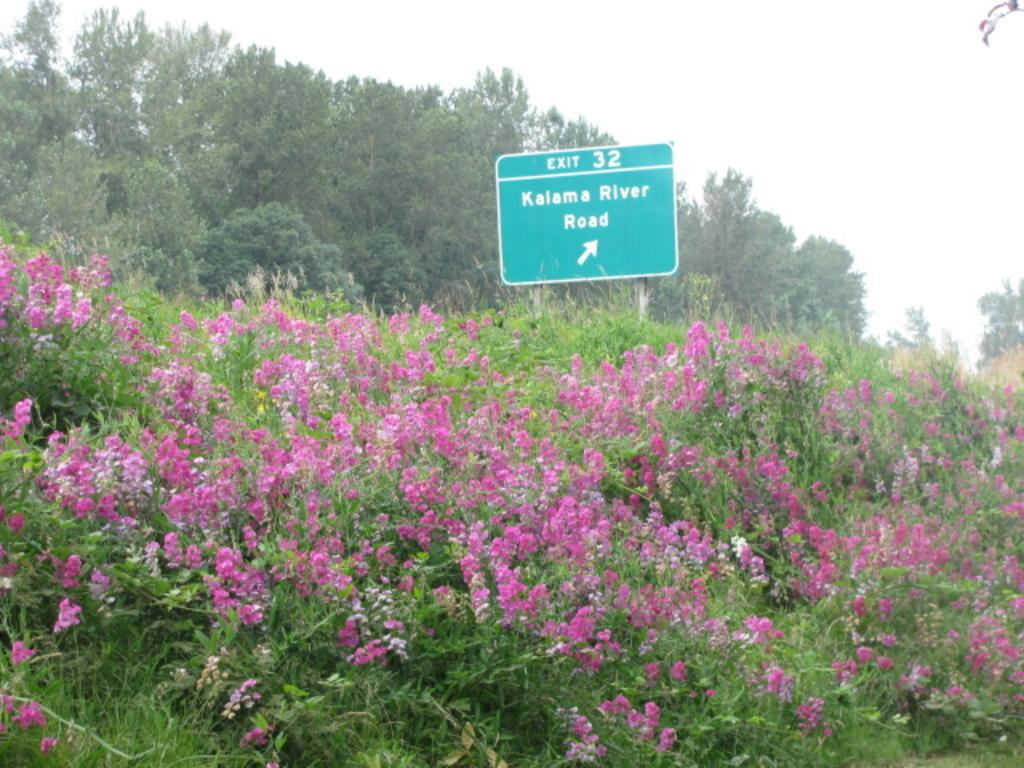What type of vegetation can be seen in the image? There are trees and plants in the image. What specific floral elements are present in the image? There are flowers in the image. What is the color of the flowers? The flowers are pink in color. What additional object can be seen in the image? There is a sign board in the image. What invention is being demonstrated in the image? There is no invention being demonstrated in the image; it primarily features trees, plants, flowers, and a sign board. 